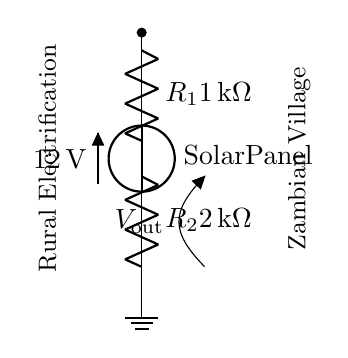What is the voltage supplied by the solar panel? The solar panel provides a voltage of twelve volts, as indicated in the circuit diagram.
Answer: twelve volts What are the values of resistors R1 and R2? Resistor R1 has a value of one thousand ohms, and resistor R2 has a value of two thousand ohms, as labeled in the circuit.
Answer: one thousand ohms and two thousand ohms What is the output voltage labeled in the circuit diagram? The output voltage is labeled as V out, which can be calculated using the voltage divider formula based on the resistor values.
Answer: V out What is the configuration of R1 and R2 in the voltage divider? R1 and R2 are connected in series, which is a typical arrangement for a voltage divider circuit.
Answer: in series How do you calculate the output voltage V out? The output voltage can be calculated using the voltage divider formula: V out equals the total voltage multiplied by the ratio of R2 to the total resistance, which is R1 plus R2. Thus, V out equals twelve volts times two thousand divided by three thousand, resulting in eight volts.
Answer: eight volts Which component primarily provides power in this circuit? The solar panel is the component that primarily provides power, supplying the necessary voltage for the entire circuit operation.
Answer: solar panel What is the purpose of the voltage divider in this setup? The purpose of the voltage divider is to reduce the voltage from the solar panel to a lower level suitable for powering devices or systems used in rural electrification.
Answer: to reduce voltage 